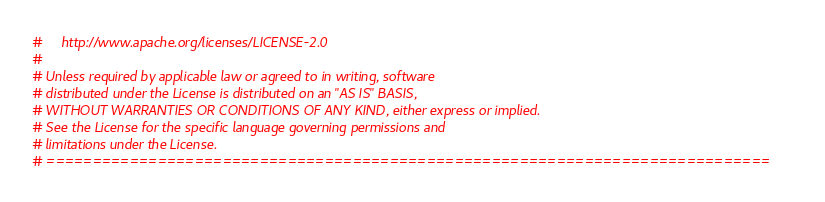Convert code to text. <code><loc_0><loc_0><loc_500><loc_500><_Python_>#     http://www.apache.org/licenses/LICENSE-2.0
#
# Unless required by applicable law or agreed to in writing, software
# distributed under the License is distributed on an "AS IS" BASIS,
# WITHOUT WARRANTIES OR CONDITIONS OF ANY KIND, either express or implied.
# See the License for the specific language governing permissions and
# limitations under the License.
# ==============================================================================

</code> 